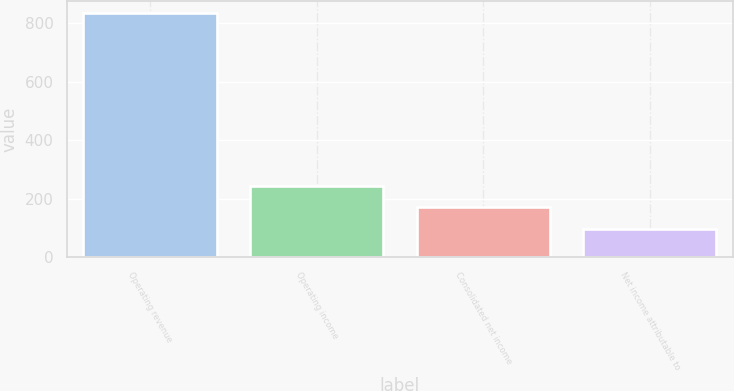Convert chart. <chart><loc_0><loc_0><loc_500><loc_500><bar_chart><fcel>Operating revenue<fcel>Operating income<fcel>Consolidated net income<fcel>Net income attributable to<nl><fcel>834.8<fcel>244<fcel>170.15<fcel>96.3<nl></chart> 